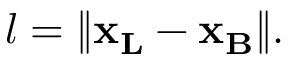<formula> <loc_0><loc_0><loc_500><loc_500>l = \| { x _ { L } } - { x _ { B } } \| .</formula> 